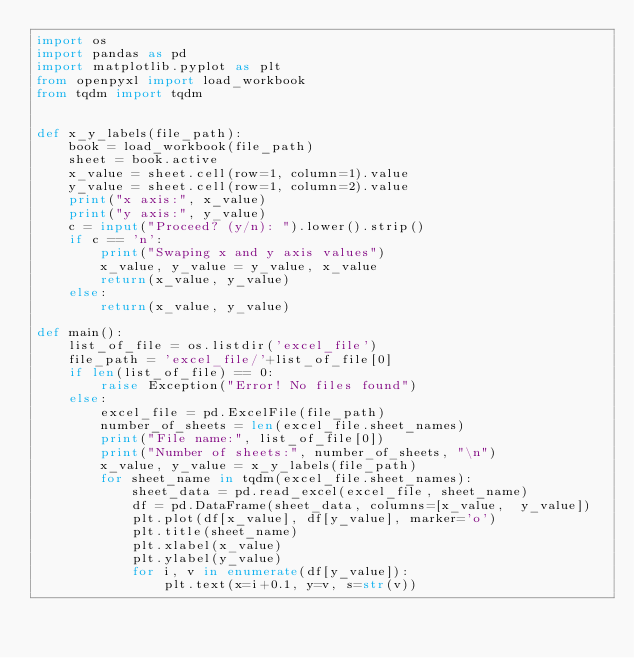<code> <loc_0><loc_0><loc_500><loc_500><_Python_>import os
import pandas as pd
import matplotlib.pyplot as plt
from openpyxl import load_workbook
from tqdm import tqdm


def x_y_labels(file_path):
    book = load_workbook(file_path)
    sheet = book.active
    x_value = sheet.cell(row=1, column=1).value
    y_value = sheet.cell(row=1, column=2).value
    print("x axis:", x_value)
    print("y axis:", y_value)
    c = input("Proceed? (y/n): ").lower().strip()
    if c == 'n':
        print("Swaping x and y axis values")
        x_value, y_value = y_value, x_value
        return(x_value, y_value)
    else:
        return(x_value, y_value)

def main():
    list_of_file = os.listdir('excel_file')
    file_path = 'excel_file/'+list_of_file[0]
    if len(list_of_file) == 0:
        raise Exception("Error! No files found")
    else:
        excel_file = pd.ExcelFile(file_path)
        number_of_sheets = len(excel_file.sheet_names)
        print("File name:", list_of_file[0])
        print("Number of sheets:", number_of_sheets, "\n")
        x_value, y_value = x_y_labels(file_path)
        for sheet_name in tqdm(excel_file.sheet_names):
            sheet_data = pd.read_excel(excel_file, sheet_name)
            df = pd.DataFrame(sheet_data, columns=[x_value,  y_value])
            plt.plot(df[x_value], df[y_value], marker='o')
            plt.title(sheet_name)
            plt.xlabel(x_value)
            plt.ylabel(y_value)
            for i, v in enumerate(df[y_value]):
                plt.text(x=i+0.1, y=v, s=str(v))</code> 